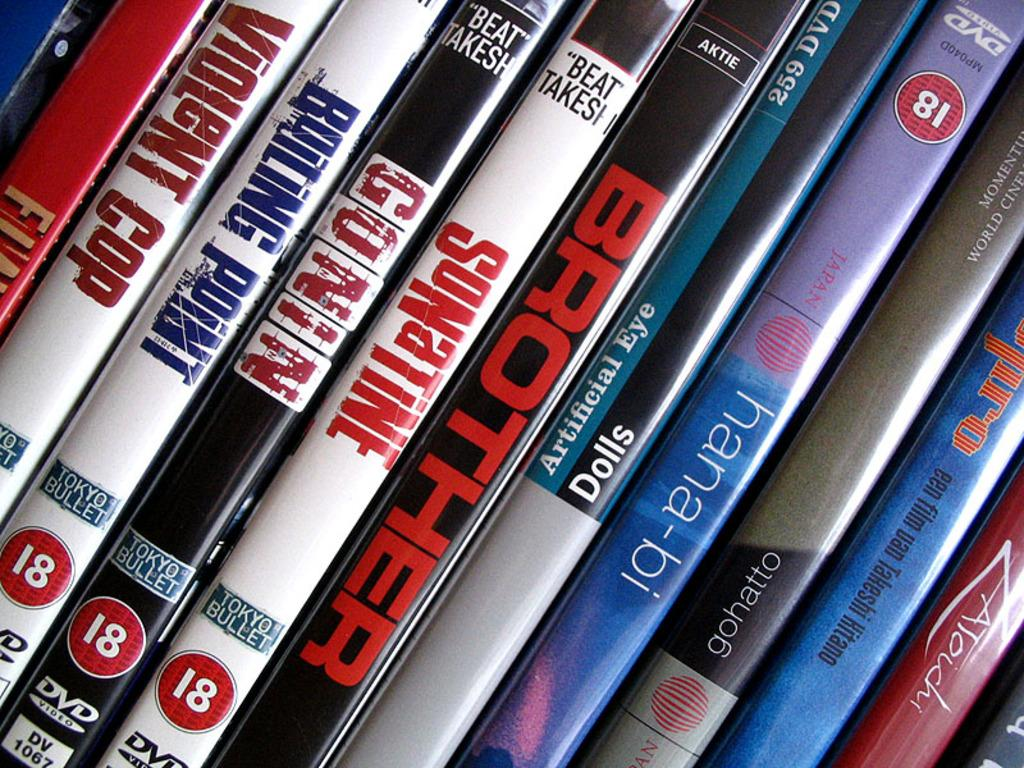<image>
Give a short and clear explanation of the subsequent image. Some Tokyo Bullet DVDs include titles such as Violent Cop, Boiling Point and Son a Time. 